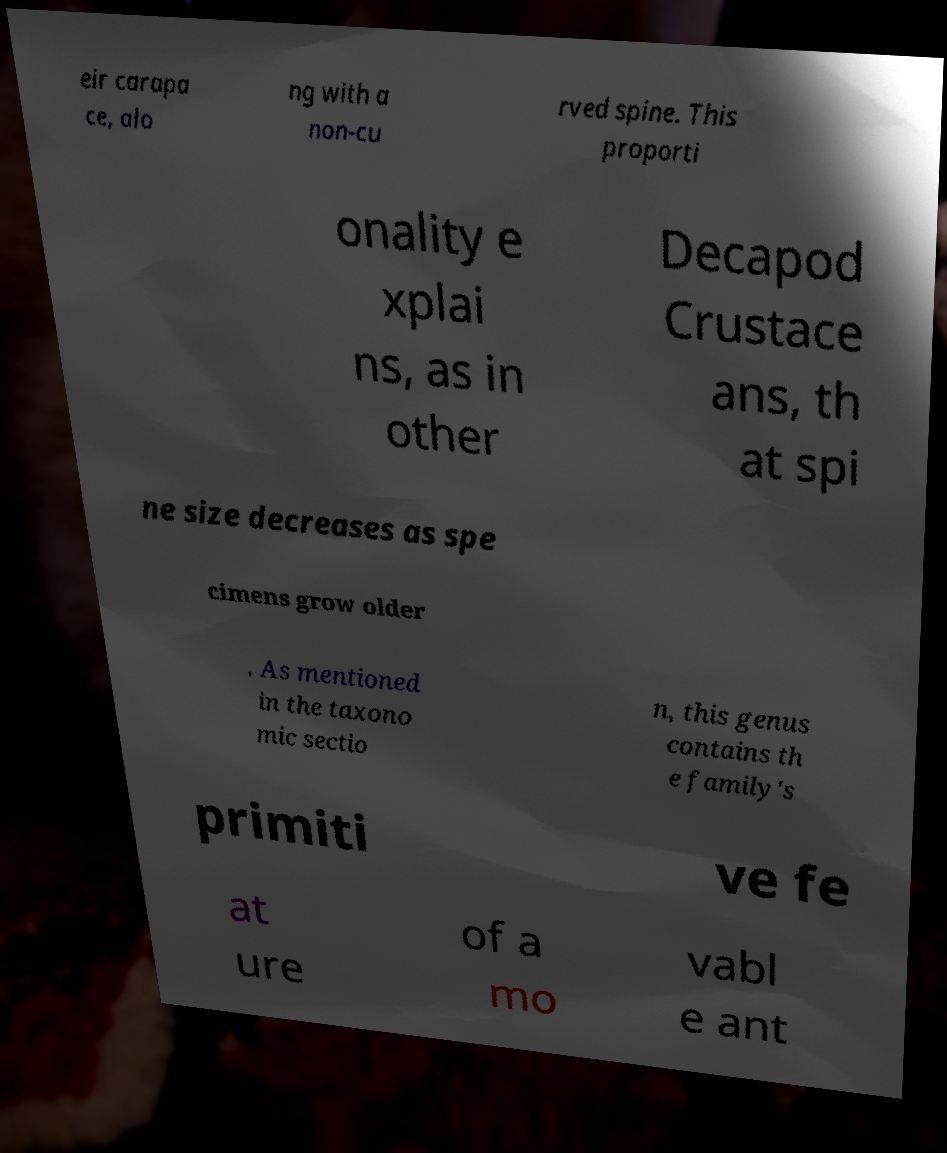Could you extract and type out the text from this image? eir carapa ce, alo ng with a non-cu rved spine. This proporti onality e xplai ns, as in other Decapod Crustace ans, th at spi ne size decreases as spe cimens grow older . As mentioned in the taxono mic sectio n, this genus contains th e family's primiti ve fe at ure of a mo vabl e ant 